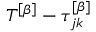Convert formula to latex. <formula><loc_0><loc_0><loc_500><loc_500>T ^ { \left [ \beta \right ] } - \tau _ { j k } ^ { \left [ \beta \right ] }</formula> 